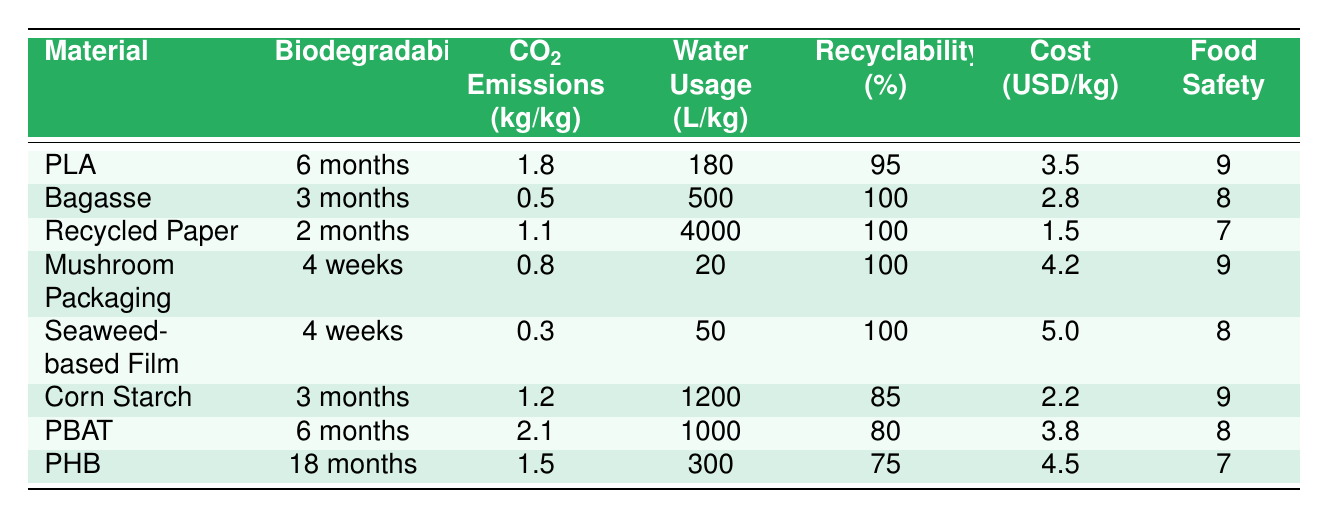What is the biodegradability rate of Bagasse? Looking at the "Biodegradability" column, Bagasse has a biodegradability rate of 3 months.
Answer: 3 months Which material has the lowest CO2 emissions per kg? By checking the "CO2 Emissions (kg/kg)" column, Bagasse has the lowest value at 0.5 kg.
Answer: Bagasse What is the average water usage of all the packaging materials listed? To find the average, sum the water usage values: (180 + 500 + 4000 + 20 + 50 + 1200 + 1000 + 300) = 6150 liters. Then, divide by 8 (the number of materials), resulting in 6150 / 8 = 768.75 liters.
Answer: 768.75 liters Is Seaweed-based Film biodegradable in under 6 months? Checking the "Biodegradability" column, Seaweed-based Film has a rate of 4 weeks, which is less than 6 months.
Answer: Yes Which material has the highest recyclability percentage? Looking at the "Recyclability (%)" column, Bagasse has the highest recyclability at 100%.
Answer: Bagasse What is the food safety rating of PBAT? From the "Food Safety" column, PBAT has a rating of 8.
Answer: 8 Which material has the highest cost per kg? In the "Cost (USD/kg)" column, Seaweed-based Film has the highest cost at 5.0 USD.
Answer: Seaweed-based Film If we consider the average biodegradability of materials that can degrade in less than 6 months, what would that be? First, identify materials degrading within 6 months: Bagasse (3 months), Recycled Paper (2 months), Mushroom Packaging (4 weeks), Seaweed-based Film (4 weeks), Corn Starch (3 months). Their biodegradability rates (in months) are approximately: 3, 2, 0.25, 0.25, 3. Average these: (3 + 2 + 0.25 + 0.25 + 3)/5 = 1.9 months.
Answer: 1.9 months What percentage of materials have a food safety rating of 9 or higher? There are 8 materials, with 4 materials rated 9 (PLA, Mushroom Packaging, Corn Starch, PBAT). The percentage is (4/8) * 100 = 50%.
Answer: 50% Is there a correlation between CO2 emissions and cost per kg? Visually comparing the "CO2 Emissions" and "Cost" columns shows that higher CO2 emissions do not consistently correlate with higher costs, as Bagasse has low emissions and lower costs. A qualitative view suggests a weak correlation.
Answer: No明确相关性 